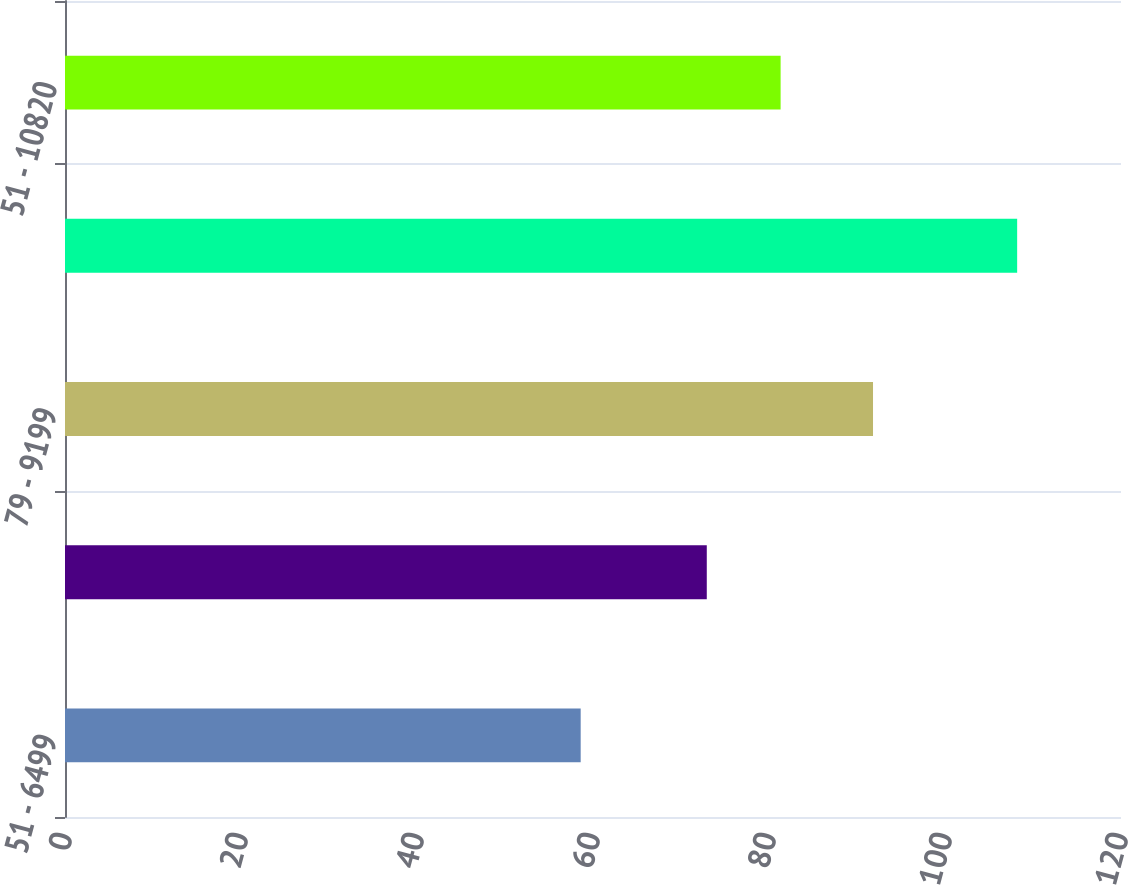Convert chart. <chart><loc_0><loc_0><loc_500><loc_500><bar_chart><fcel>51 - 6499<fcel>65 - 7890<fcel>79 - 9199<fcel>92 - 10820<fcel>51 - 10820<nl><fcel>58.6<fcel>72.93<fcel>91.82<fcel>108.2<fcel>81.32<nl></chart> 